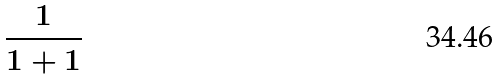<formula> <loc_0><loc_0><loc_500><loc_500>\frac { 1 } { 1 + 1 }</formula> 